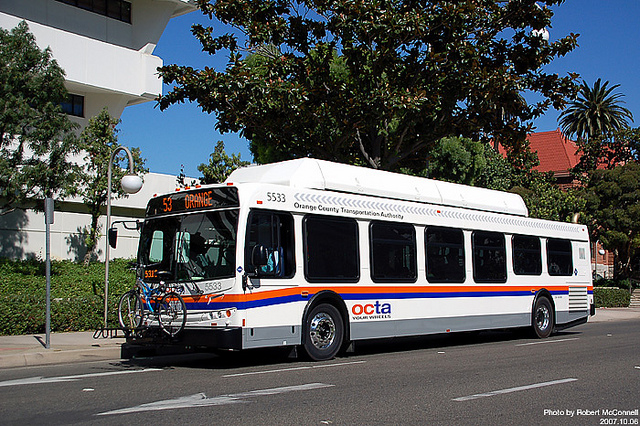Please extract the text content from this image. Orange 09 10 2007 McConnell Robert by Photo ORANGE 53 5533 Octa S533 